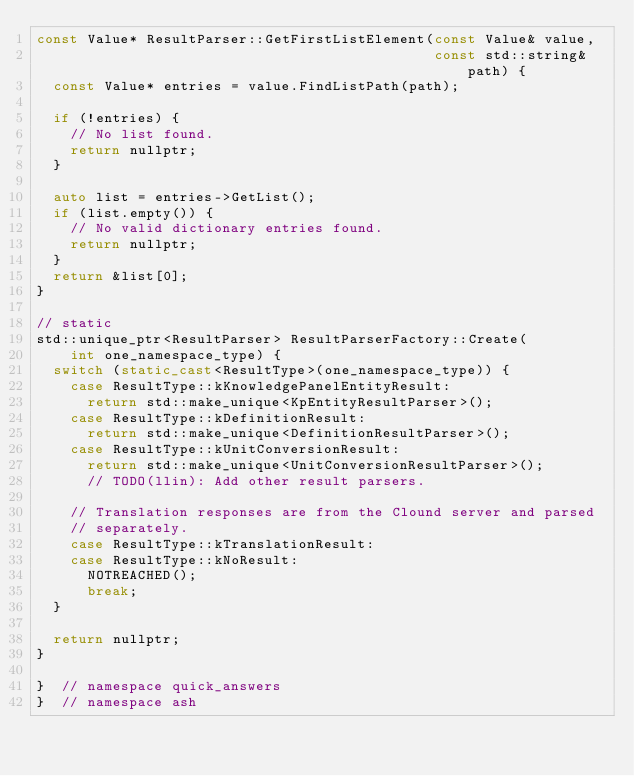<code> <loc_0><loc_0><loc_500><loc_500><_C++_>const Value* ResultParser::GetFirstListElement(const Value& value,
                                               const std::string& path) {
  const Value* entries = value.FindListPath(path);

  if (!entries) {
    // No list found.
    return nullptr;
  }

  auto list = entries->GetList();
  if (list.empty()) {
    // No valid dictionary entries found.
    return nullptr;
  }
  return &list[0];
}

// static
std::unique_ptr<ResultParser> ResultParserFactory::Create(
    int one_namespace_type) {
  switch (static_cast<ResultType>(one_namespace_type)) {
    case ResultType::kKnowledgePanelEntityResult:
      return std::make_unique<KpEntityResultParser>();
    case ResultType::kDefinitionResult:
      return std::make_unique<DefinitionResultParser>();
    case ResultType::kUnitConversionResult:
      return std::make_unique<UnitConversionResultParser>();
      // TODO(llin): Add other result parsers.

    // Translation responses are from the Clound server and parsed
    // separately.
    case ResultType::kTranslationResult:
    case ResultType::kNoResult:
      NOTREACHED();
      break;
  }

  return nullptr;
}

}  // namespace quick_answers
}  // namespace ash
</code> 